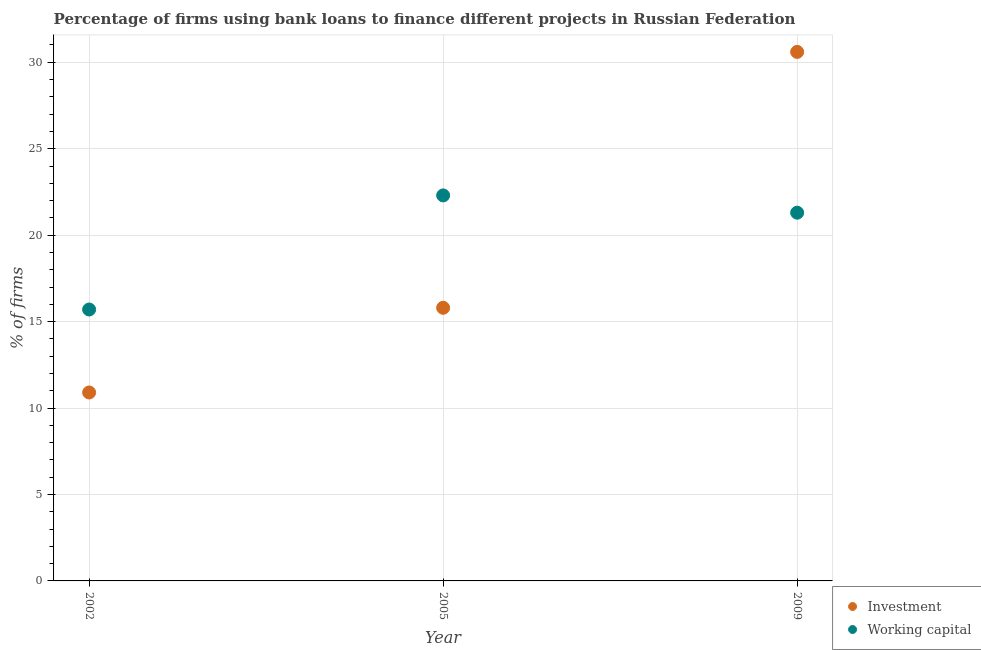How many different coloured dotlines are there?
Ensure brevity in your answer.  2. What is the percentage of firms using banks to finance investment in 2009?
Provide a succinct answer. 30.6. Across all years, what is the maximum percentage of firms using banks to finance investment?
Keep it short and to the point. 30.6. In which year was the percentage of firms using banks to finance investment minimum?
Keep it short and to the point. 2002. What is the total percentage of firms using banks to finance investment in the graph?
Give a very brief answer. 57.3. What is the difference between the percentage of firms using banks to finance investment in 2005 and that in 2009?
Provide a succinct answer. -14.8. What is the difference between the percentage of firms using banks to finance investment in 2002 and the percentage of firms using banks to finance working capital in 2009?
Offer a terse response. -10.4. What is the average percentage of firms using banks to finance working capital per year?
Ensure brevity in your answer.  19.77. In the year 2002, what is the difference between the percentage of firms using banks to finance working capital and percentage of firms using banks to finance investment?
Give a very brief answer. 4.8. In how many years, is the percentage of firms using banks to finance investment greater than 10 %?
Your answer should be very brief. 3. What is the ratio of the percentage of firms using banks to finance investment in 2005 to that in 2009?
Make the answer very short. 0.52. What is the difference between the highest and the lowest percentage of firms using banks to finance working capital?
Make the answer very short. 6.6. Is the sum of the percentage of firms using banks to finance working capital in 2002 and 2005 greater than the maximum percentage of firms using banks to finance investment across all years?
Your answer should be very brief. Yes. Does the percentage of firms using banks to finance investment monotonically increase over the years?
Offer a terse response. Yes. Is the percentage of firms using banks to finance working capital strictly greater than the percentage of firms using banks to finance investment over the years?
Your response must be concise. No. How many dotlines are there?
Provide a succinct answer. 2. What is the difference between two consecutive major ticks on the Y-axis?
Provide a short and direct response. 5. Does the graph contain any zero values?
Give a very brief answer. No. How many legend labels are there?
Your response must be concise. 2. How are the legend labels stacked?
Give a very brief answer. Vertical. What is the title of the graph?
Make the answer very short. Percentage of firms using bank loans to finance different projects in Russian Federation. What is the label or title of the X-axis?
Provide a succinct answer. Year. What is the label or title of the Y-axis?
Provide a succinct answer. % of firms. What is the % of firms of Investment in 2005?
Offer a very short reply. 15.8. What is the % of firms of Working capital in 2005?
Ensure brevity in your answer.  22.3. What is the % of firms of Investment in 2009?
Your answer should be very brief. 30.6. What is the % of firms of Working capital in 2009?
Your answer should be very brief. 21.3. Across all years, what is the maximum % of firms in Investment?
Offer a terse response. 30.6. Across all years, what is the maximum % of firms of Working capital?
Your response must be concise. 22.3. Across all years, what is the minimum % of firms in Investment?
Your response must be concise. 10.9. What is the total % of firms in Investment in the graph?
Your answer should be compact. 57.3. What is the total % of firms in Working capital in the graph?
Provide a succinct answer. 59.3. What is the difference between the % of firms of Investment in 2002 and that in 2005?
Make the answer very short. -4.9. What is the difference between the % of firms of Investment in 2002 and that in 2009?
Offer a terse response. -19.7. What is the difference between the % of firms of Working capital in 2002 and that in 2009?
Keep it short and to the point. -5.6. What is the difference between the % of firms in Investment in 2005 and that in 2009?
Make the answer very short. -14.8. What is the difference between the % of firms of Working capital in 2005 and that in 2009?
Make the answer very short. 1. What is the difference between the % of firms in Investment in 2002 and the % of firms in Working capital in 2009?
Provide a succinct answer. -10.4. What is the average % of firms of Working capital per year?
Make the answer very short. 19.77. In the year 2002, what is the difference between the % of firms of Investment and % of firms of Working capital?
Your answer should be very brief. -4.8. In the year 2009, what is the difference between the % of firms in Investment and % of firms in Working capital?
Provide a succinct answer. 9.3. What is the ratio of the % of firms of Investment in 2002 to that in 2005?
Your response must be concise. 0.69. What is the ratio of the % of firms of Working capital in 2002 to that in 2005?
Provide a succinct answer. 0.7. What is the ratio of the % of firms in Investment in 2002 to that in 2009?
Offer a terse response. 0.36. What is the ratio of the % of firms of Working capital in 2002 to that in 2009?
Your answer should be very brief. 0.74. What is the ratio of the % of firms of Investment in 2005 to that in 2009?
Offer a very short reply. 0.52. What is the ratio of the % of firms in Working capital in 2005 to that in 2009?
Provide a succinct answer. 1.05. What is the difference between the highest and the lowest % of firms of Investment?
Your answer should be compact. 19.7. 